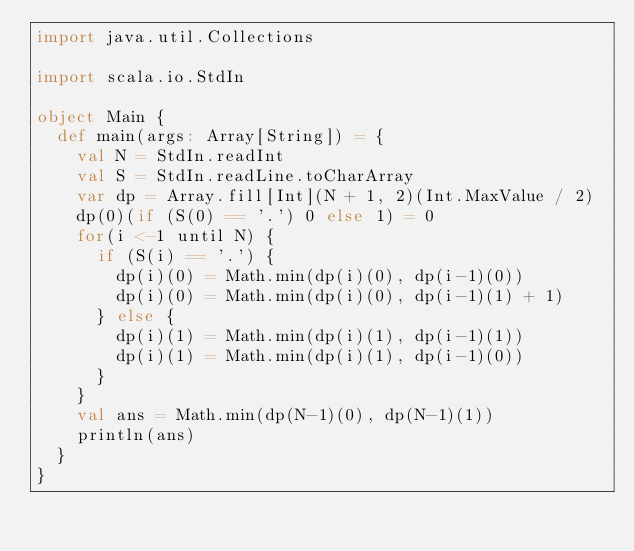<code> <loc_0><loc_0><loc_500><loc_500><_Scala_>import java.util.Collections

import scala.io.StdIn

object Main {
  def main(args: Array[String]) = {
    val N = StdIn.readInt
    val S = StdIn.readLine.toCharArray
    var dp = Array.fill[Int](N + 1, 2)(Int.MaxValue / 2)
    dp(0)(if (S(0) == '.') 0 else 1) = 0
    for(i <-1 until N) {
      if (S(i) == '.') {
        dp(i)(0) = Math.min(dp(i)(0), dp(i-1)(0))
        dp(i)(0) = Math.min(dp(i)(0), dp(i-1)(1) + 1)
      } else {
        dp(i)(1) = Math.min(dp(i)(1), dp(i-1)(1))
        dp(i)(1) = Math.min(dp(i)(1), dp(i-1)(0))
      }
    }
    val ans = Math.min(dp(N-1)(0), dp(N-1)(1))
    println(ans)
  }
}
</code> 